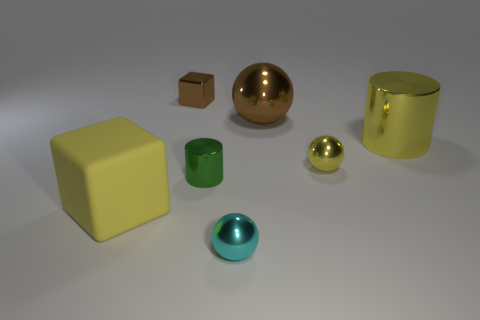Subtract all big brown shiny spheres. How many spheres are left? 2 Add 1 small metallic things. How many objects exist? 8 Subtract all yellow blocks. How many blocks are left? 1 Subtract all cubes. How many objects are left? 5 Subtract all yellow balls. How many green cylinders are left? 1 Subtract all large brown metal things. Subtract all large brown balls. How many objects are left? 5 Add 7 big shiny cylinders. How many big shiny cylinders are left? 8 Add 3 large shiny objects. How many large shiny objects exist? 5 Subtract 0 green blocks. How many objects are left? 7 Subtract 2 blocks. How many blocks are left? 0 